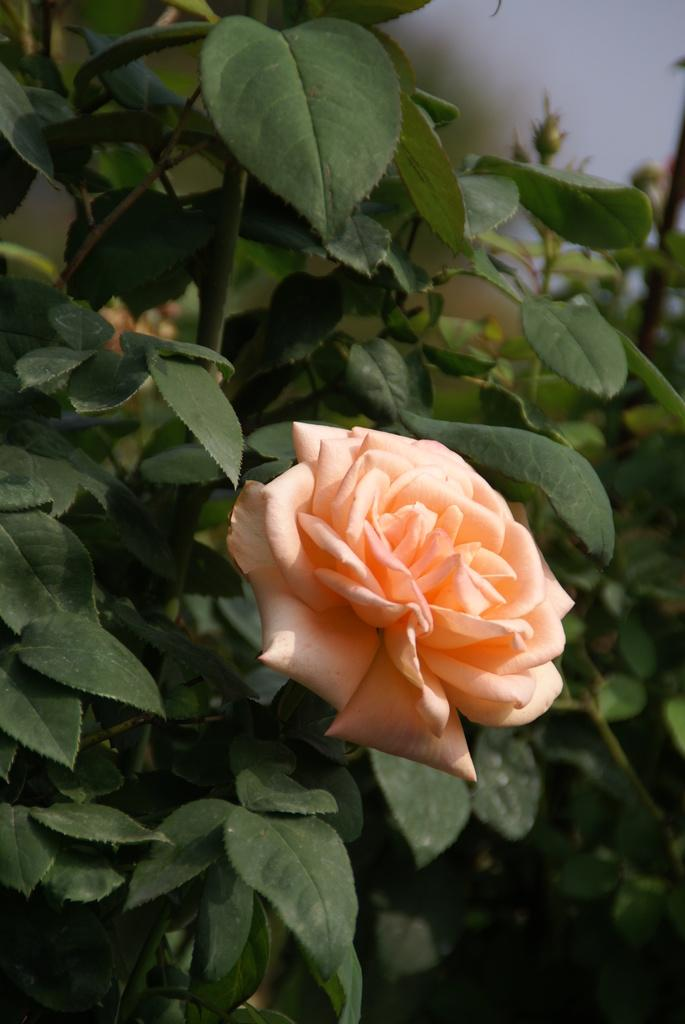What type of plant can be seen in the image? There is a flower in the image. What else is present on the plant besides the flower? There are leaves in the image. What type of breakfast is being served on the railway in the image? There is no breakfast or railway present in the image; it only features a flower and leaves. 